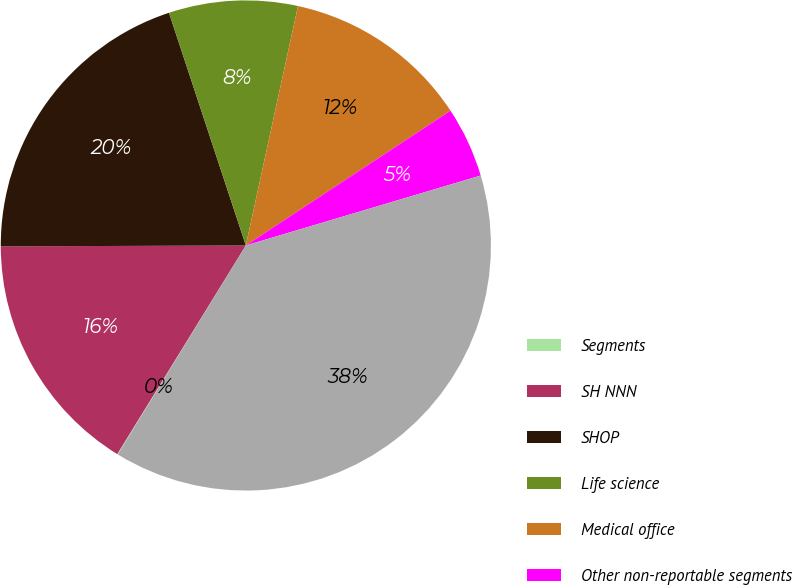Convert chart to OTSL. <chart><loc_0><loc_0><loc_500><loc_500><pie_chart><fcel>Segments<fcel>SH NNN<fcel>SHOP<fcel>Life science<fcel>Medical office<fcel>Other non-reportable segments<fcel>Total revenues<nl><fcel>0.04%<fcel>16.15%<fcel>19.98%<fcel>8.49%<fcel>12.32%<fcel>4.66%<fcel>38.36%<nl></chart> 